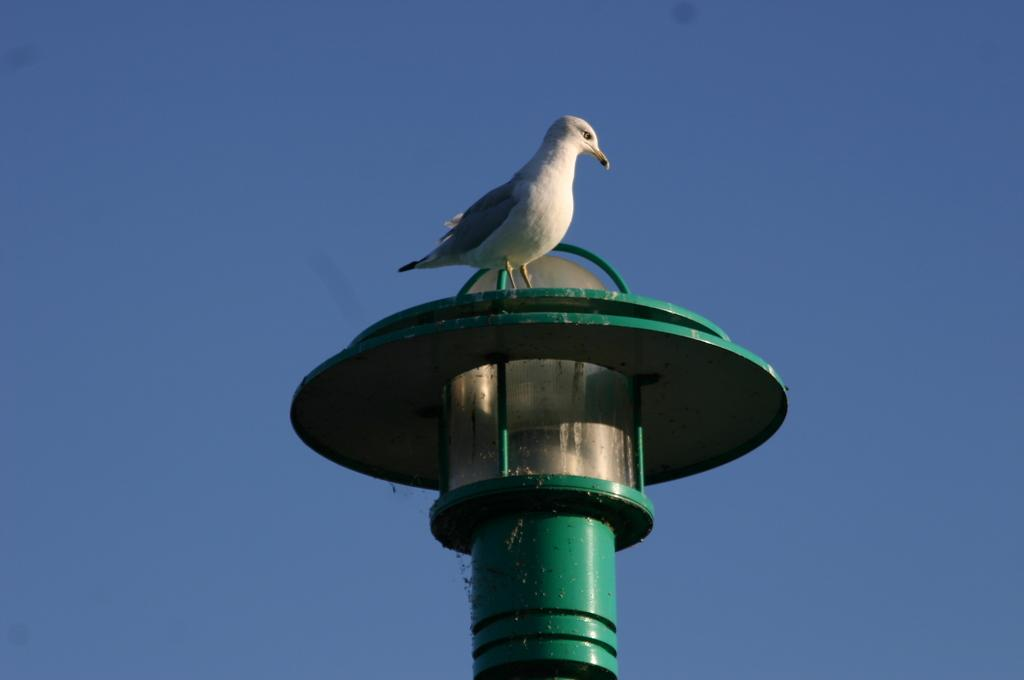What type of animal can be seen in the image? There is a white bird in the image. Where is the bird located? The bird is on a light pole in the image. What can be seen attached to the light pole? There is a bulb in the image. What is the condition of the sky in the background of the image? The sky is clear in the background of the image. How long does it take for the bird to teach the rock in the image? There is no rock present in the image, and therefore no teaching can occur between the bird and a rock. 